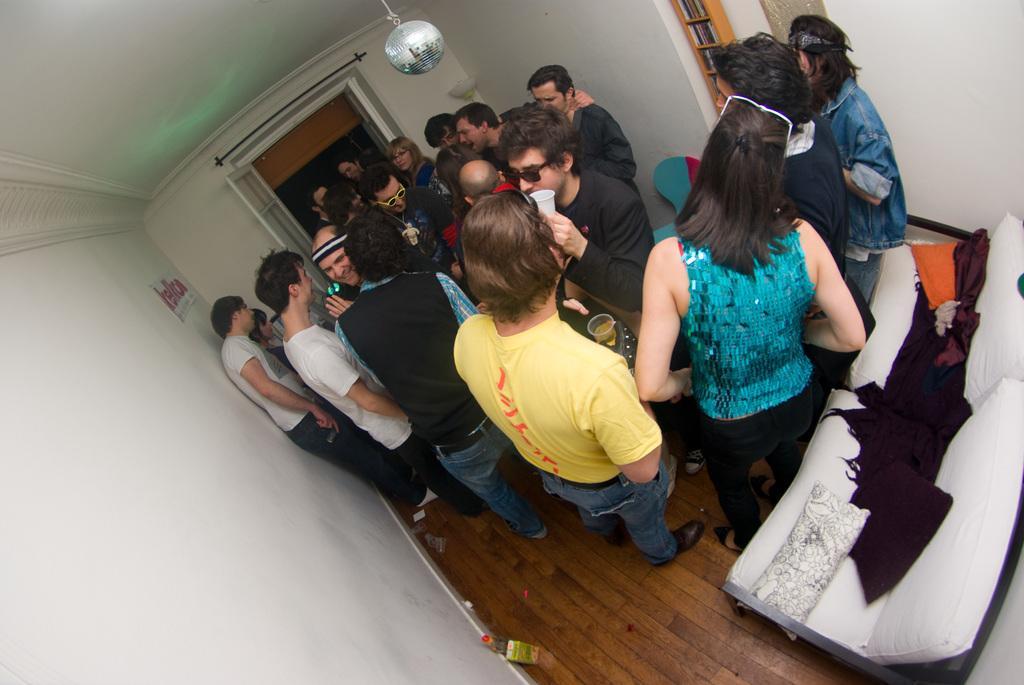Describe this image in one or two sentences. In this image we can see many people. On the left side there is a wall. On the right side there is a sofa with pillow and some other items. Also there is a window. In the back there is a door. At the top there is a light. Also there is a person wearing goggles and holding a glass. 